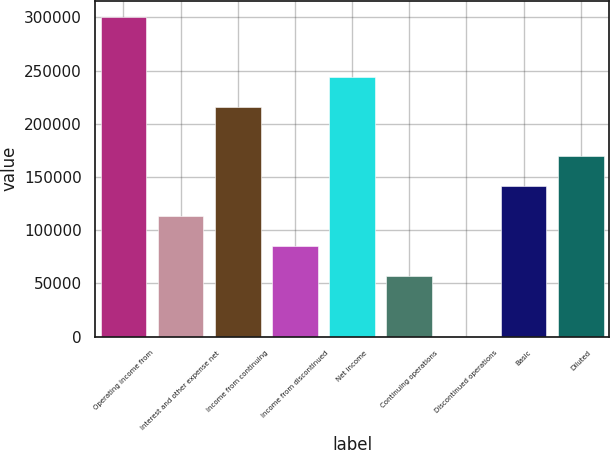Convert chart to OTSL. <chart><loc_0><loc_0><loc_500><loc_500><bar_chart><fcel>Operating income from<fcel>Interest and other expense net<fcel>Income from continuing<fcel>Income from discontinued<fcel>Net income<fcel>Continuing operations<fcel>Discontinued operations<fcel>Basic<fcel>Diluted<nl><fcel>300626<fcel>113226<fcel>215706<fcel>84919.9<fcel>244013<fcel>56613.3<fcel>0.17<fcel>141533<fcel>169840<nl></chart> 